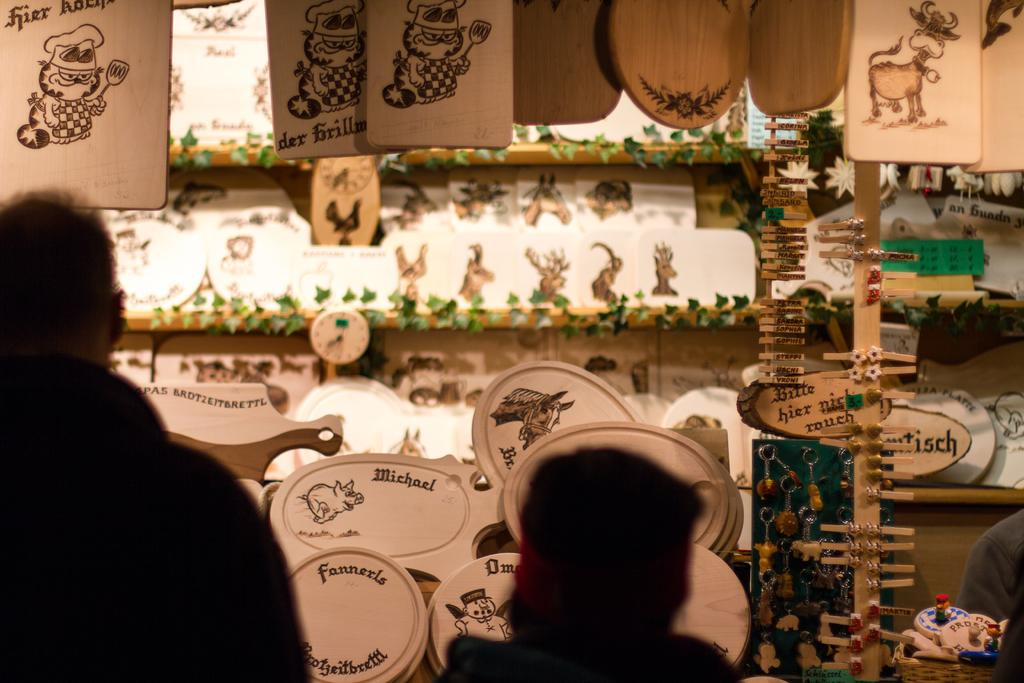How many people are in the image? There are people in the image. What can be seen in the background of the image? There are wooden objects, keychains, a basket, and objects arranged in a rack in the background. Can you describe the arrangement of the objects in the background? Objects are arranged in a rack in the background. Where is the person located in the image? There is a person in the right bottom of the image. Reasoning: Let' Let's think step by step in order to produce the conversation. We start by acknowledging the presence of people in the image, as stated in the first fact. Then, we describe the various objects and arrangements visible in the background, based on the remaining facts. We ensure that each question is specific and can be answered definitively with the information given. Absurd Question/Answer: What type of nail is being used to play the game of cub in the image? There is no nail or game of cub present in the image. Can you describe the chess pieces on the board in the image? There is no chessboard or pieces present in the image. 